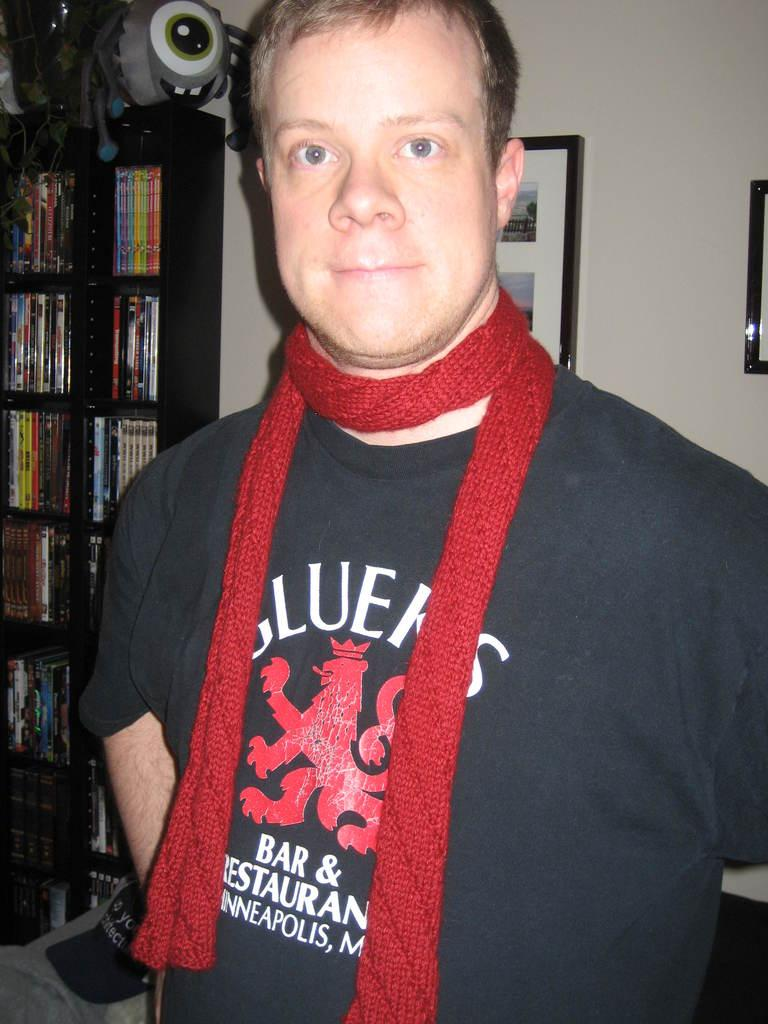<image>
Render a clear and concise summary of the photo. A man with a red scarf around his neck in a black shirt that is from some bar and restaurant. 